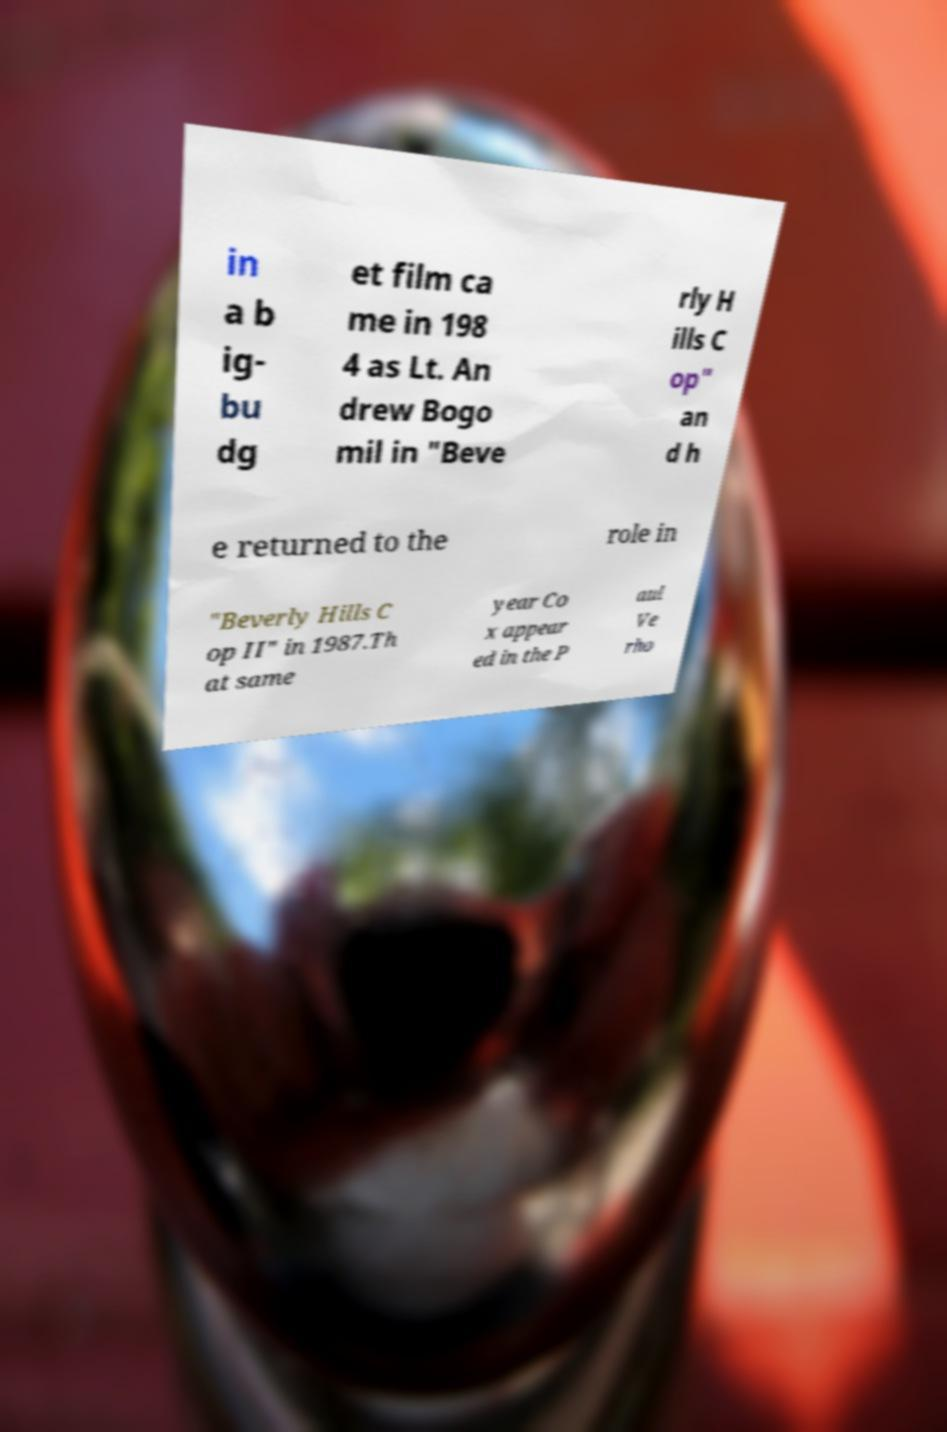There's text embedded in this image that I need extracted. Can you transcribe it verbatim? in a b ig- bu dg et film ca me in 198 4 as Lt. An drew Bogo mil in "Beve rly H ills C op" an d h e returned to the role in "Beverly Hills C op II" in 1987.Th at same year Co x appear ed in the P aul Ve rho 